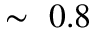<formula> <loc_0><loc_0><loc_500><loc_500>\sim 0 . 8</formula> 